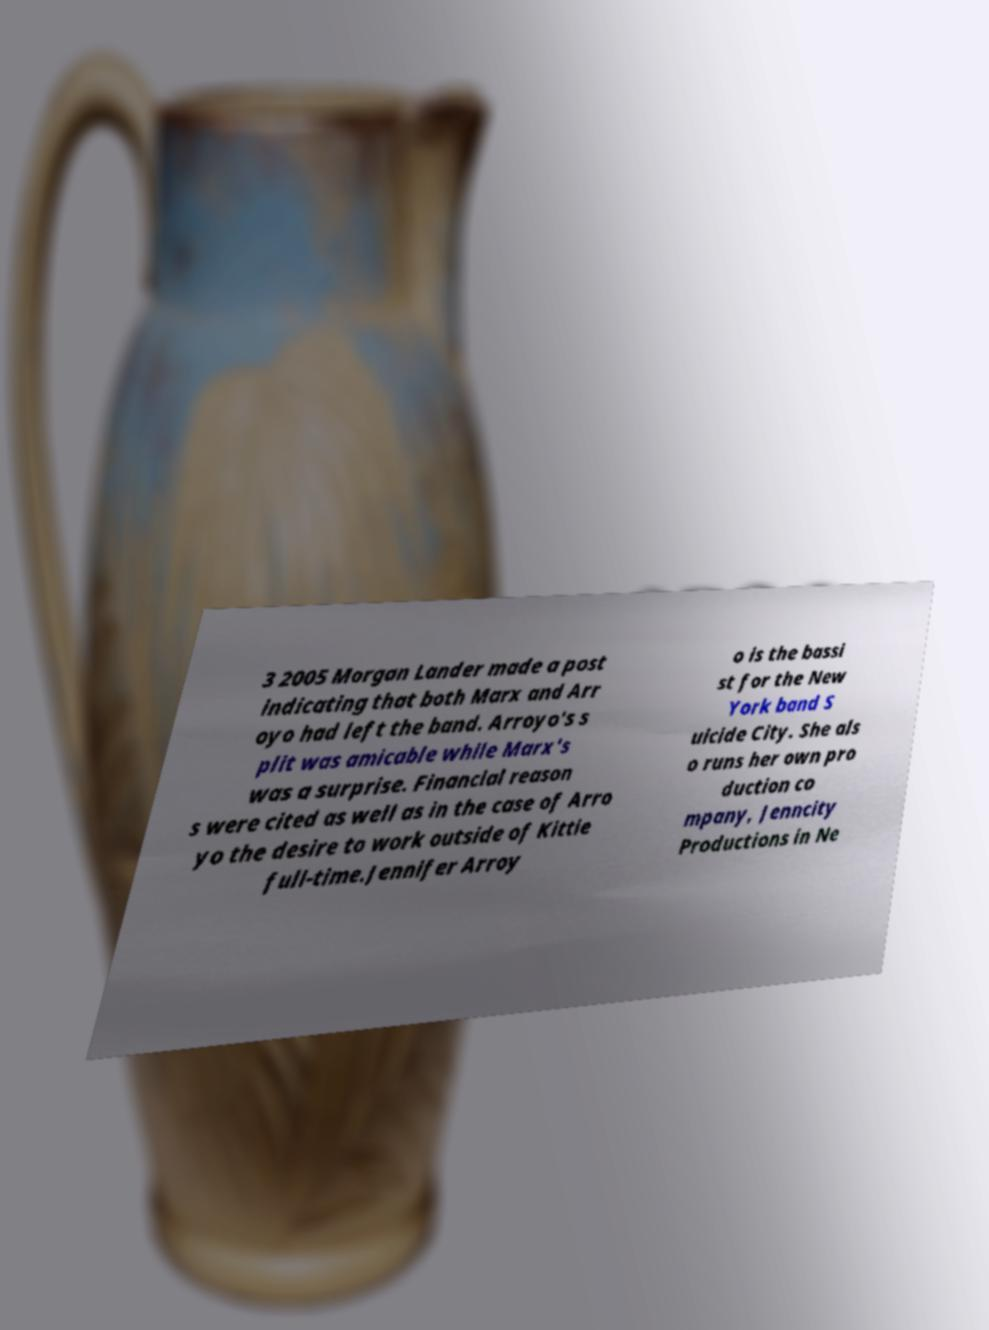Can you accurately transcribe the text from the provided image for me? 3 2005 Morgan Lander made a post indicating that both Marx and Arr oyo had left the band. Arroyo's s plit was amicable while Marx's was a surprise. Financial reason s were cited as well as in the case of Arro yo the desire to work outside of Kittie full-time.Jennifer Arroy o is the bassi st for the New York band S uicide City. She als o runs her own pro duction co mpany, Jenncity Productions in Ne 